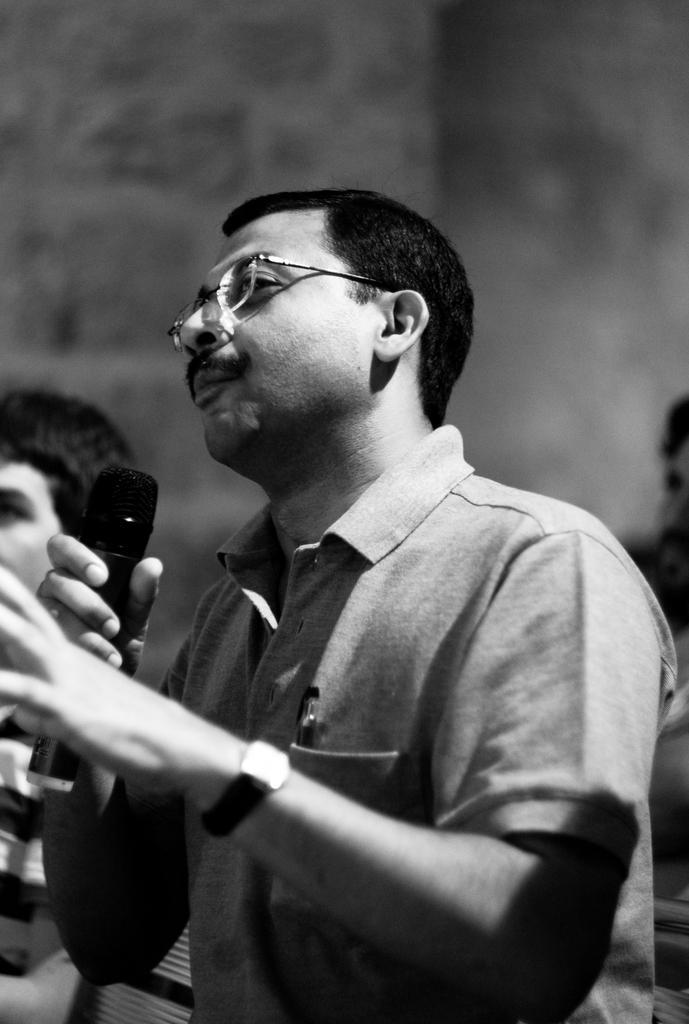Please provide a concise description of this image. In this I can see a man wearing t-shirt and holding a mike in his hand and looking at the left side. In the background also there are few people. This person is wearing a watch to his left hand. This is a black and white image. 